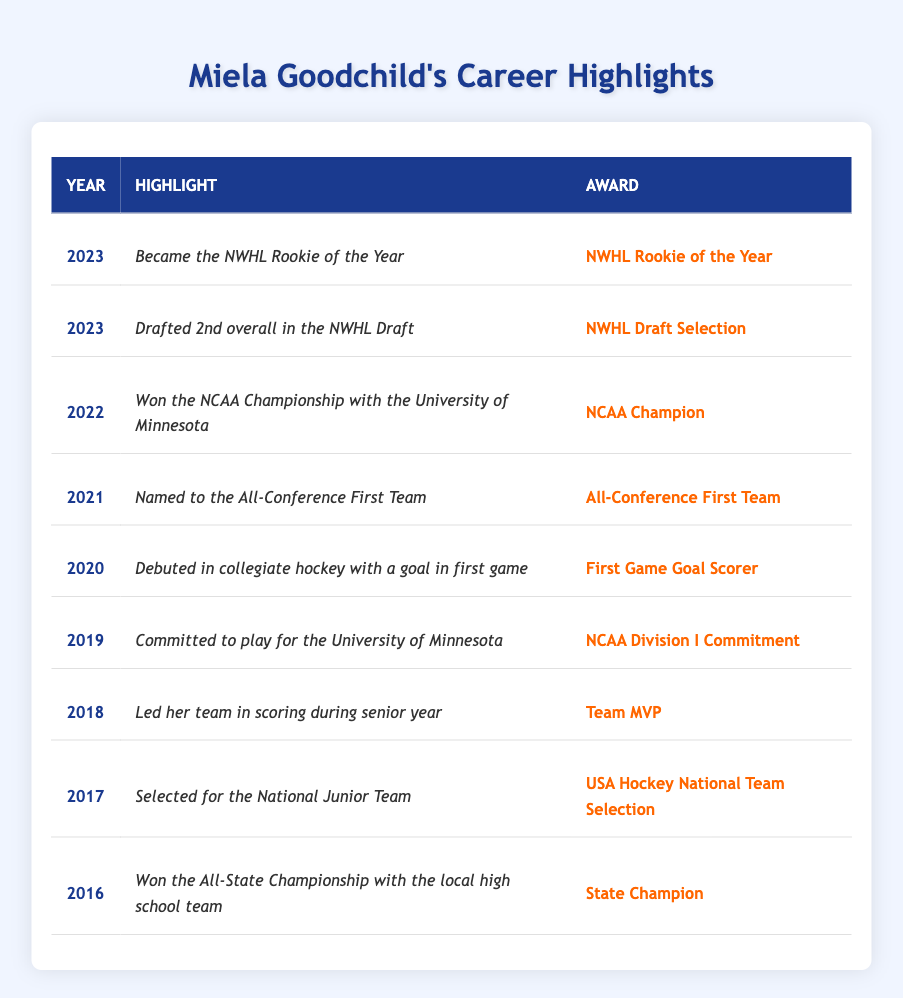What year did Miela Goodchild win the NCAA Championship? The table indicates Miela Goodchild won the NCAA Championship in 2022.
Answer: 2022 How many awards did Miela Goodchild receive in her collegiate career? From the entries, the years 2020 to 2023 show she received 4 awards (First Game Goal Scorer, All-Conference First Team, NCAA Champion, NWHL Rookie of the Year).
Answer: 4 Did Miela Goodchild lead her team in scoring during her senior year? Yes, according to the table, she was noted for leading her team in scoring during her senior year in 2018.
Answer: Yes What was the highlight of Miela Goodchild's career in 2023? The table shows that in 2023, she became the NWHL Rookie of the Year.
Answer: Became the NWHL Rookie of the Year Count the total number of years Miela Goodchild has been recognized between 2016 and 2023. From 2016 to 2023, there are 8 different years listed with highlights and awards for her career.
Answer: 8 What award did she receive in 2019? In 2019, Miela Goodchild was recognized for her commitment to play for the University of Minnesota, receiving the award for NCAA Division I Commitment.
Answer: NCAA Division I Commitment Was Miela Goodchild ever selected for a national team? Yes, in 2017, she was selected for the National Junior Team as noted in the table.
Answer: Yes What is the difference in the number of awards she received in the years 2021 and 2022? In 2021, she received 1 award, whereas in 2022, she received 1 award. The difference in number is 0 (1 - 1 = 0).
Answer: 0 In which year did Miela commit to play for the University of Minnesota? The table indicates she committed to play for the University of Minnesota in 2019.
Answer: 2019 What award did she receive in her first collegiate game? In her first collegiate game, Miela Goodchild was recognized as the First Game Goal Scorer in 2020.
Answer: First Game Goal Scorer How many total championships or significant recognitions has she achieved between 2016 and 2022? In the years of 2016 (State Champion), 2022 (NCAA Champion), she achieved 2 championship-related recognitions.
Answer: 2 What was Miela Goodchild recognized for in 2021? She was named to the All-Conference First Team in 2021 according to the table.
Answer: All-Conference First Team 